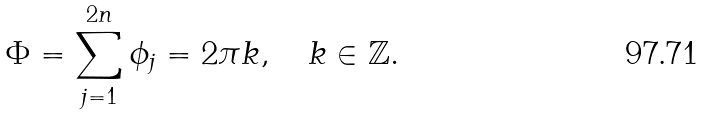<formula> <loc_0><loc_0><loc_500><loc_500>\Phi = \sum _ { j = 1 } ^ { 2 n } \phi _ { j } = 2 \pi k , \quad k \in \mathbb { Z } .</formula> 